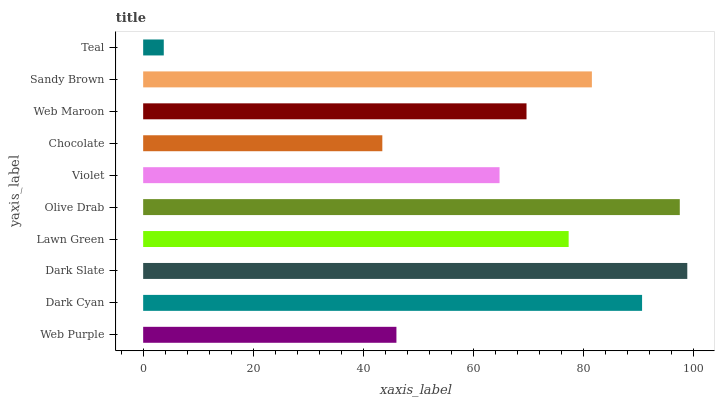Is Teal the minimum?
Answer yes or no. Yes. Is Dark Slate the maximum?
Answer yes or no. Yes. Is Dark Cyan the minimum?
Answer yes or no. No. Is Dark Cyan the maximum?
Answer yes or no. No. Is Dark Cyan greater than Web Purple?
Answer yes or no. Yes. Is Web Purple less than Dark Cyan?
Answer yes or no. Yes. Is Web Purple greater than Dark Cyan?
Answer yes or no. No. Is Dark Cyan less than Web Purple?
Answer yes or no. No. Is Lawn Green the high median?
Answer yes or no. Yes. Is Web Maroon the low median?
Answer yes or no. Yes. Is Violet the high median?
Answer yes or no. No. Is Web Purple the low median?
Answer yes or no. No. 